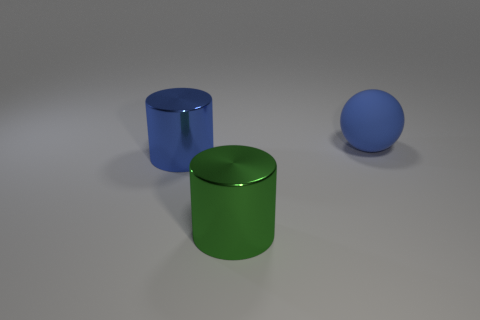Add 2 cylinders. How many objects exist? 5 Subtract all blue cylinders. How many cylinders are left? 1 Subtract all cylinders. How many objects are left? 1 Add 2 cylinders. How many cylinders exist? 4 Subtract 0 brown balls. How many objects are left? 3 Subtract 1 cylinders. How many cylinders are left? 1 Subtract all purple cylinders. Subtract all purple cubes. How many cylinders are left? 2 Subtract all purple spheres. How many cyan cylinders are left? 0 Subtract all cylinders. Subtract all large balls. How many objects are left? 0 Add 2 large blue metallic cylinders. How many large blue metallic cylinders are left? 3 